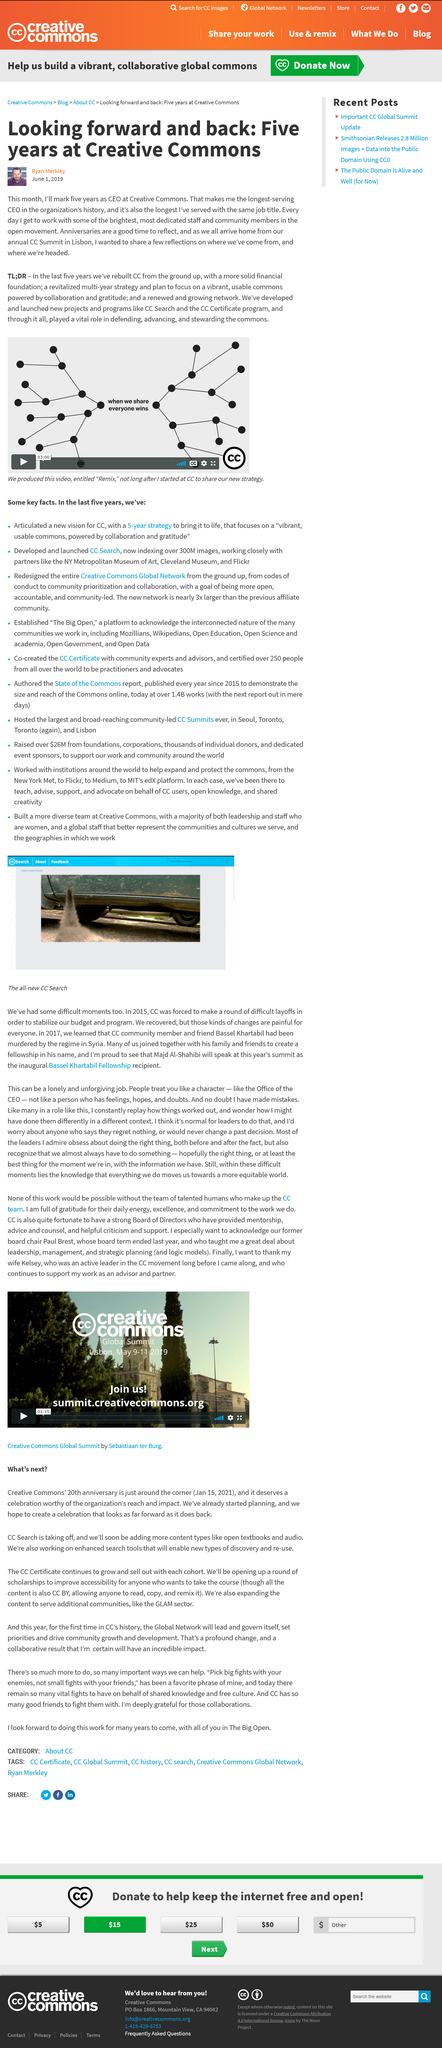Give some essential details in this illustration. Anniversaries are an excellent time for reflection, as they provide an opportunity for individuals to reflect on their past experiences and accomplishments, and to consider their future goals and aspirations. The last Summit was held in Lisbon. Ryan has been the CEO for 5 years. 